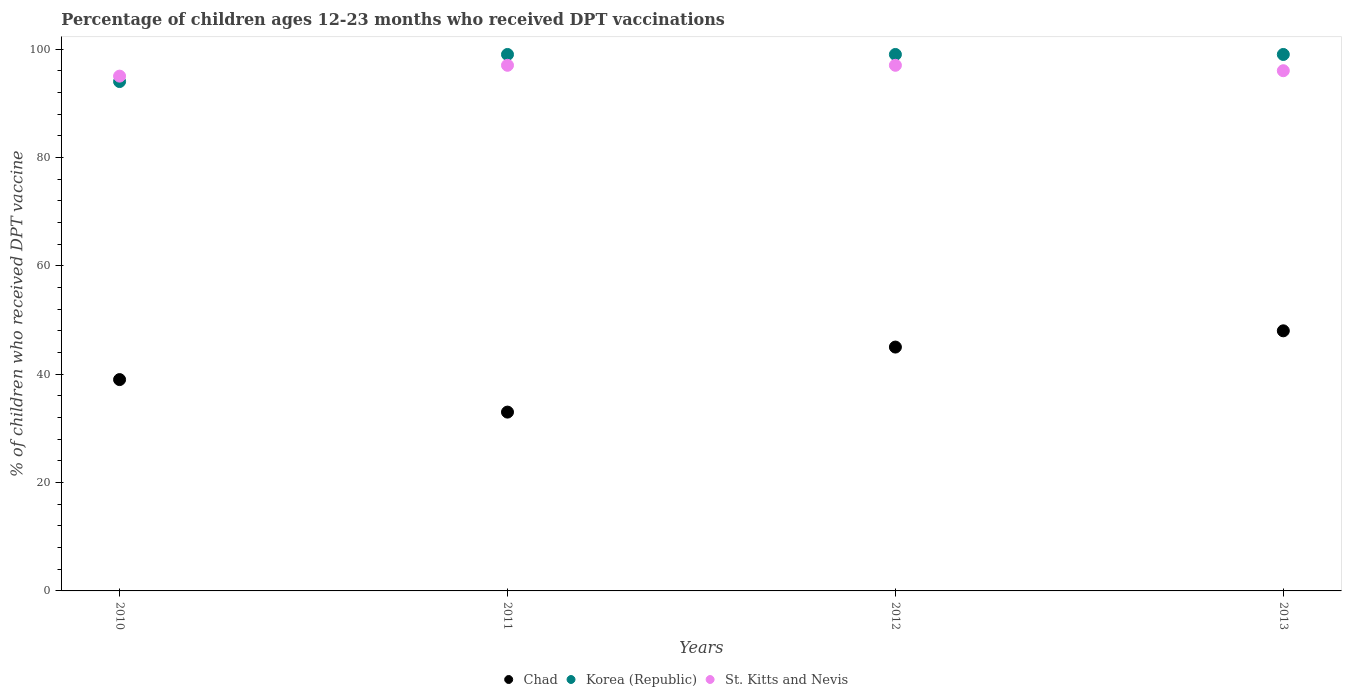Is the number of dotlines equal to the number of legend labels?
Your answer should be very brief. Yes. What is the percentage of children who received DPT vaccination in St. Kitts and Nevis in 2011?
Offer a very short reply. 97. Across all years, what is the maximum percentage of children who received DPT vaccination in St. Kitts and Nevis?
Offer a very short reply. 97. Across all years, what is the minimum percentage of children who received DPT vaccination in Korea (Republic)?
Keep it short and to the point. 94. What is the total percentage of children who received DPT vaccination in Korea (Republic) in the graph?
Your answer should be very brief. 391. What is the difference between the percentage of children who received DPT vaccination in St. Kitts and Nevis in 2011 and the percentage of children who received DPT vaccination in Chad in 2013?
Your answer should be very brief. 49. What is the average percentage of children who received DPT vaccination in St. Kitts and Nevis per year?
Offer a terse response. 96.25. In the year 2013, what is the difference between the percentage of children who received DPT vaccination in Korea (Republic) and percentage of children who received DPT vaccination in Chad?
Provide a succinct answer. 51. What is the ratio of the percentage of children who received DPT vaccination in St. Kitts and Nevis in 2010 to that in 2012?
Your response must be concise. 0.98. What is the difference between the highest and the lowest percentage of children who received DPT vaccination in St. Kitts and Nevis?
Make the answer very short. 2. Is the sum of the percentage of children who received DPT vaccination in St. Kitts and Nevis in 2010 and 2011 greater than the maximum percentage of children who received DPT vaccination in Korea (Republic) across all years?
Your response must be concise. Yes. Does the percentage of children who received DPT vaccination in Chad monotonically increase over the years?
Keep it short and to the point. No. Is the percentage of children who received DPT vaccination in Korea (Republic) strictly less than the percentage of children who received DPT vaccination in Chad over the years?
Provide a succinct answer. No. How many dotlines are there?
Your answer should be very brief. 3. Are the values on the major ticks of Y-axis written in scientific E-notation?
Offer a very short reply. No. Does the graph contain any zero values?
Offer a very short reply. No. Does the graph contain grids?
Ensure brevity in your answer.  No. How are the legend labels stacked?
Offer a terse response. Horizontal. What is the title of the graph?
Your response must be concise. Percentage of children ages 12-23 months who received DPT vaccinations. Does "Cuba" appear as one of the legend labels in the graph?
Provide a short and direct response. No. What is the label or title of the Y-axis?
Your response must be concise. % of children who received DPT vaccine. What is the % of children who received DPT vaccine in Chad in 2010?
Offer a terse response. 39. What is the % of children who received DPT vaccine of Korea (Republic) in 2010?
Offer a very short reply. 94. What is the % of children who received DPT vaccine of Korea (Republic) in 2011?
Offer a very short reply. 99. What is the % of children who received DPT vaccine in St. Kitts and Nevis in 2011?
Make the answer very short. 97. What is the % of children who received DPT vaccine of Korea (Republic) in 2012?
Offer a very short reply. 99. What is the % of children who received DPT vaccine of St. Kitts and Nevis in 2012?
Make the answer very short. 97. What is the % of children who received DPT vaccine of Chad in 2013?
Your answer should be very brief. 48. What is the % of children who received DPT vaccine in St. Kitts and Nevis in 2013?
Provide a succinct answer. 96. Across all years, what is the maximum % of children who received DPT vaccine of Chad?
Your answer should be compact. 48. Across all years, what is the maximum % of children who received DPT vaccine in Korea (Republic)?
Give a very brief answer. 99. Across all years, what is the maximum % of children who received DPT vaccine of St. Kitts and Nevis?
Provide a short and direct response. 97. Across all years, what is the minimum % of children who received DPT vaccine of Chad?
Give a very brief answer. 33. Across all years, what is the minimum % of children who received DPT vaccine of Korea (Republic)?
Offer a terse response. 94. What is the total % of children who received DPT vaccine of Chad in the graph?
Offer a terse response. 165. What is the total % of children who received DPT vaccine of Korea (Republic) in the graph?
Your response must be concise. 391. What is the total % of children who received DPT vaccine of St. Kitts and Nevis in the graph?
Your answer should be very brief. 385. What is the difference between the % of children who received DPT vaccine in Chad in 2010 and that in 2011?
Make the answer very short. 6. What is the difference between the % of children who received DPT vaccine of Chad in 2010 and that in 2012?
Ensure brevity in your answer.  -6. What is the difference between the % of children who received DPT vaccine in St. Kitts and Nevis in 2010 and that in 2012?
Ensure brevity in your answer.  -2. What is the difference between the % of children who received DPT vaccine of Chad in 2010 and that in 2013?
Offer a very short reply. -9. What is the difference between the % of children who received DPT vaccine of Korea (Republic) in 2010 and that in 2013?
Provide a short and direct response. -5. What is the difference between the % of children who received DPT vaccine of St. Kitts and Nevis in 2010 and that in 2013?
Your answer should be very brief. -1. What is the difference between the % of children who received DPT vaccine in Chad in 2011 and that in 2012?
Make the answer very short. -12. What is the difference between the % of children who received DPT vaccine of Korea (Republic) in 2011 and that in 2012?
Offer a very short reply. 0. What is the difference between the % of children who received DPT vaccine in Chad in 2011 and that in 2013?
Make the answer very short. -15. What is the difference between the % of children who received DPT vaccine of Chad in 2012 and that in 2013?
Provide a succinct answer. -3. What is the difference between the % of children who received DPT vaccine in Chad in 2010 and the % of children who received DPT vaccine in Korea (Republic) in 2011?
Offer a very short reply. -60. What is the difference between the % of children who received DPT vaccine in Chad in 2010 and the % of children who received DPT vaccine in St. Kitts and Nevis in 2011?
Make the answer very short. -58. What is the difference between the % of children who received DPT vaccine of Korea (Republic) in 2010 and the % of children who received DPT vaccine of St. Kitts and Nevis in 2011?
Make the answer very short. -3. What is the difference between the % of children who received DPT vaccine in Chad in 2010 and the % of children who received DPT vaccine in Korea (Republic) in 2012?
Offer a very short reply. -60. What is the difference between the % of children who received DPT vaccine of Chad in 2010 and the % of children who received DPT vaccine of St. Kitts and Nevis in 2012?
Your answer should be compact. -58. What is the difference between the % of children who received DPT vaccine in Korea (Republic) in 2010 and the % of children who received DPT vaccine in St. Kitts and Nevis in 2012?
Provide a succinct answer. -3. What is the difference between the % of children who received DPT vaccine in Chad in 2010 and the % of children who received DPT vaccine in Korea (Republic) in 2013?
Offer a terse response. -60. What is the difference between the % of children who received DPT vaccine in Chad in 2010 and the % of children who received DPT vaccine in St. Kitts and Nevis in 2013?
Give a very brief answer. -57. What is the difference between the % of children who received DPT vaccine of Korea (Republic) in 2010 and the % of children who received DPT vaccine of St. Kitts and Nevis in 2013?
Provide a succinct answer. -2. What is the difference between the % of children who received DPT vaccine of Chad in 2011 and the % of children who received DPT vaccine of Korea (Republic) in 2012?
Make the answer very short. -66. What is the difference between the % of children who received DPT vaccine of Chad in 2011 and the % of children who received DPT vaccine of St. Kitts and Nevis in 2012?
Your response must be concise. -64. What is the difference between the % of children who received DPT vaccine of Korea (Republic) in 2011 and the % of children who received DPT vaccine of St. Kitts and Nevis in 2012?
Offer a very short reply. 2. What is the difference between the % of children who received DPT vaccine in Chad in 2011 and the % of children who received DPT vaccine in Korea (Republic) in 2013?
Offer a very short reply. -66. What is the difference between the % of children who received DPT vaccine in Chad in 2011 and the % of children who received DPT vaccine in St. Kitts and Nevis in 2013?
Offer a very short reply. -63. What is the difference between the % of children who received DPT vaccine of Korea (Republic) in 2011 and the % of children who received DPT vaccine of St. Kitts and Nevis in 2013?
Give a very brief answer. 3. What is the difference between the % of children who received DPT vaccine in Chad in 2012 and the % of children who received DPT vaccine in Korea (Republic) in 2013?
Keep it short and to the point. -54. What is the difference between the % of children who received DPT vaccine of Chad in 2012 and the % of children who received DPT vaccine of St. Kitts and Nevis in 2013?
Provide a short and direct response. -51. What is the difference between the % of children who received DPT vaccine in Korea (Republic) in 2012 and the % of children who received DPT vaccine in St. Kitts and Nevis in 2013?
Provide a succinct answer. 3. What is the average % of children who received DPT vaccine of Chad per year?
Provide a succinct answer. 41.25. What is the average % of children who received DPT vaccine in Korea (Republic) per year?
Offer a very short reply. 97.75. What is the average % of children who received DPT vaccine of St. Kitts and Nevis per year?
Your answer should be very brief. 96.25. In the year 2010, what is the difference between the % of children who received DPT vaccine in Chad and % of children who received DPT vaccine in Korea (Republic)?
Ensure brevity in your answer.  -55. In the year 2010, what is the difference between the % of children who received DPT vaccine of Chad and % of children who received DPT vaccine of St. Kitts and Nevis?
Make the answer very short. -56. In the year 2011, what is the difference between the % of children who received DPT vaccine in Chad and % of children who received DPT vaccine in Korea (Republic)?
Your answer should be compact. -66. In the year 2011, what is the difference between the % of children who received DPT vaccine in Chad and % of children who received DPT vaccine in St. Kitts and Nevis?
Your answer should be compact. -64. In the year 2011, what is the difference between the % of children who received DPT vaccine of Korea (Republic) and % of children who received DPT vaccine of St. Kitts and Nevis?
Provide a succinct answer. 2. In the year 2012, what is the difference between the % of children who received DPT vaccine in Chad and % of children who received DPT vaccine in Korea (Republic)?
Give a very brief answer. -54. In the year 2012, what is the difference between the % of children who received DPT vaccine of Chad and % of children who received DPT vaccine of St. Kitts and Nevis?
Make the answer very short. -52. In the year 2013, what is the difference between the % of children who received DPT vaccine of Chad and % of children who received DPT vaccine of Korea (Republic)?
Provide a short and direct response. -51. In the year 2013, what is the difference between the % of children who received DPT vaccine in Chad and % of children who received DPT vaccine in St. Kitts and Nevis?
Keep it short and to the point. -48. In the year 2013, what is the difference between the % of children who received DPT vaccine of Korea (Republic) and % of children who received DPT vaccine of St. Kitts and Nevis?
Keep it short and to the point. 3. What is the ratio of the % of children who received DPT vaccine in Chad in 2010 to that in 2011?
Offer a very short reply. 1.18. What is the ratio of the % of children who received DPT vaccine in Korea (Republic) in 2010 to that in 2011?
Offer a very short reply. 0.95. What is the ratio of the % of children who received DPT vaccine in St. Kitts and Nevis in 2010 to that in 2011?
Provide a succinct answer. 0.98. What is the ratio of the % of children who received DPT vaccine in Chad in 2010 to that in 2012?
Your answer should be compact. 0.87. What is the ratio of the % of children who received DPT vaccine in Korea (Republic) in 2010 to that in 2012?
Ensure brevity in your answer.  0.95. What is the ratio of the % of children who received DPT vaccine of St. Kitts and Nevis in 2010 to that in 2012?
Offer a very short reply. 0.98. What is the ratio of the % of children who received DPT vaccine of Chad in 2010 to that in 2013?
Provide a succinct answer. 0.81. What is the ratio of the % of children who received DPT vaccine of Korea (Republic) in 2010 to that in 2013?
Give a very brief answer. 0.95. What is the ratio of the % of children who received DPT vaccine of Chad in 2011 to that in 2012?
Keep it short and to the point. 0.73. What is the ratio of the % of children who received DPT vaccine of Korea (Republic) in 2011 to that in 2012?
Keep it short and to the point. 1. What is the ratio of the % of children who received DPT vaccine of St. Kitts and Nevis in 2011 to that in 2012?
Ensure brevity in your answer.  1. What is the ratio of the % of children who received DPT vaccine in Chad in 2011 to that in 2013?
Your answer should be very brief. 0.69. What is the ratio of the % of children who received DPT vaccine of Korea (Republic) in 2011 to that in 2013?
Your answer should be very brief. 1. What is the ratio of the % of children who received DPT vaccine of St. Kitts and Nevis in 2011 to that in 2013?
Keep it short and to the point. 1.01. What is the ratio of the % of children who received DPT vaccine of St. Kitts and Nevis in 2012 to that in 2013?
Your answer should be compact. 1.01. What is the difference between the highest and the second highest % of children who received DPT vaccine in Korea (Republic)?
Give a very brief answer. 0. What is the difference between the highest and the second highest % of children who received DPT vaccine in St. Kitts and Nevis?
Give a very brief answer. 0. What is the difference between the highest and the lowest % of children who received DPT vaccine in Chad?
Ensure brevity in your answer.  15. What is the difference between the highest and the lowest % of children who received DPT vaccine of St. Kitts and Nevis?
Ensure brevity in your answer.  2. 